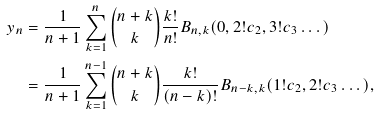<formula> <loc_0><loc_0><loc_500><loc_500>y _ { n } & = \frac { 1 } { n + 1 } \sum _ { k = 1 } ^ { n } \binom { n + k } { k } \frac { k ! } { n ! } B _ { n , k } ( 0 , 2 ! c _ { 2 } , 3 ! c _ { 3 } \dots ) \\ & = \frac { 1 } { n + 1 } \sum _ { k = 1 } ^ { n - 1 } \binom { n + k } { k } \frac { k ! } { ( n - k ) ! } B _ { n - k , k } ( 1 ! c _ { 2 } , 2 ! c _ { 3 } \dots ) ,</formula> 